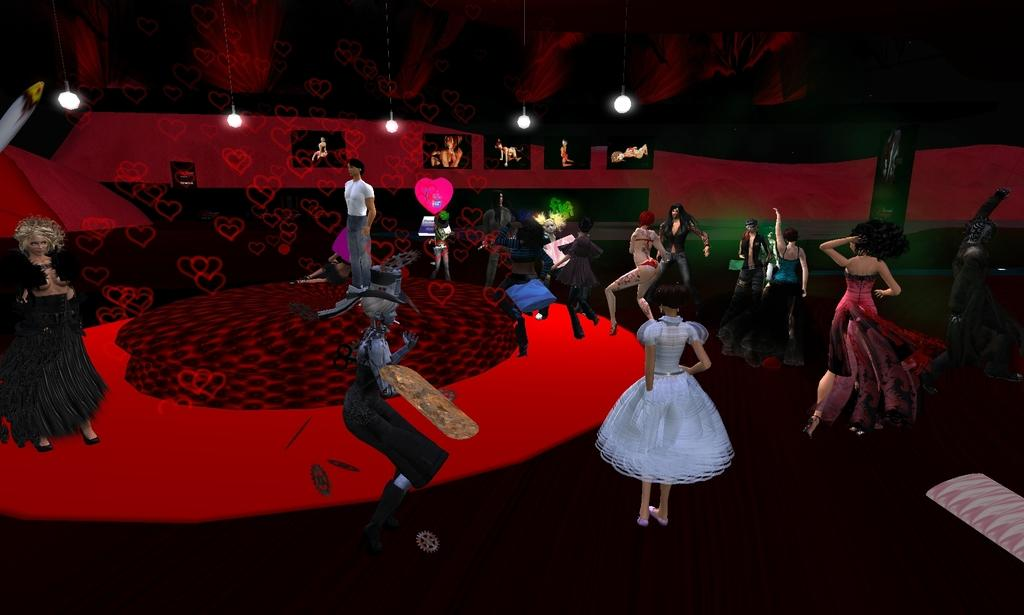What type of content is featured in the image? The image contains an animation. What are the people in the animation doing? The people are standing in the animation. Where are the people standing in the animation? The people are standing on the floor in the animation. What can be seen on the top of the animation? There are lightings on the top in the animation. Can you tell me how many people are walking on the sidewalk in the animation? There is no sidewalk present in the animation; it features people standing on the floor. What type of current can be seen flowing near the seashore in the animation? There is no seashore or current present in the animation; it is an indoor scene with people standing on the floor. 